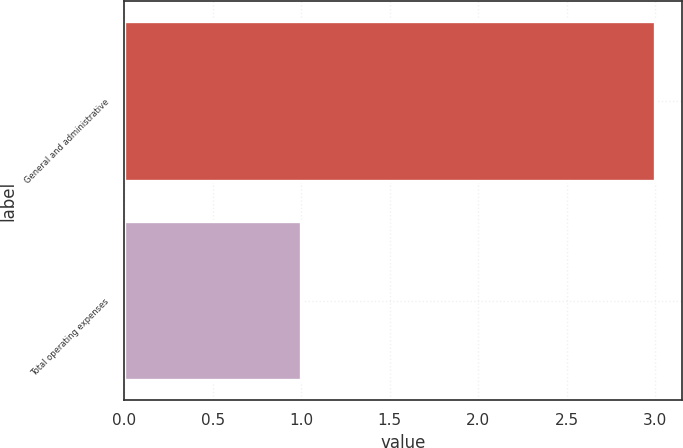Convert chart. <chart><loc_0><loc_0><loc_500><loc_500><bar_chart><fcel>General and administrative<fcel>Total operating expenses<nl><fcel>3<fcel>1<nl></chart> 